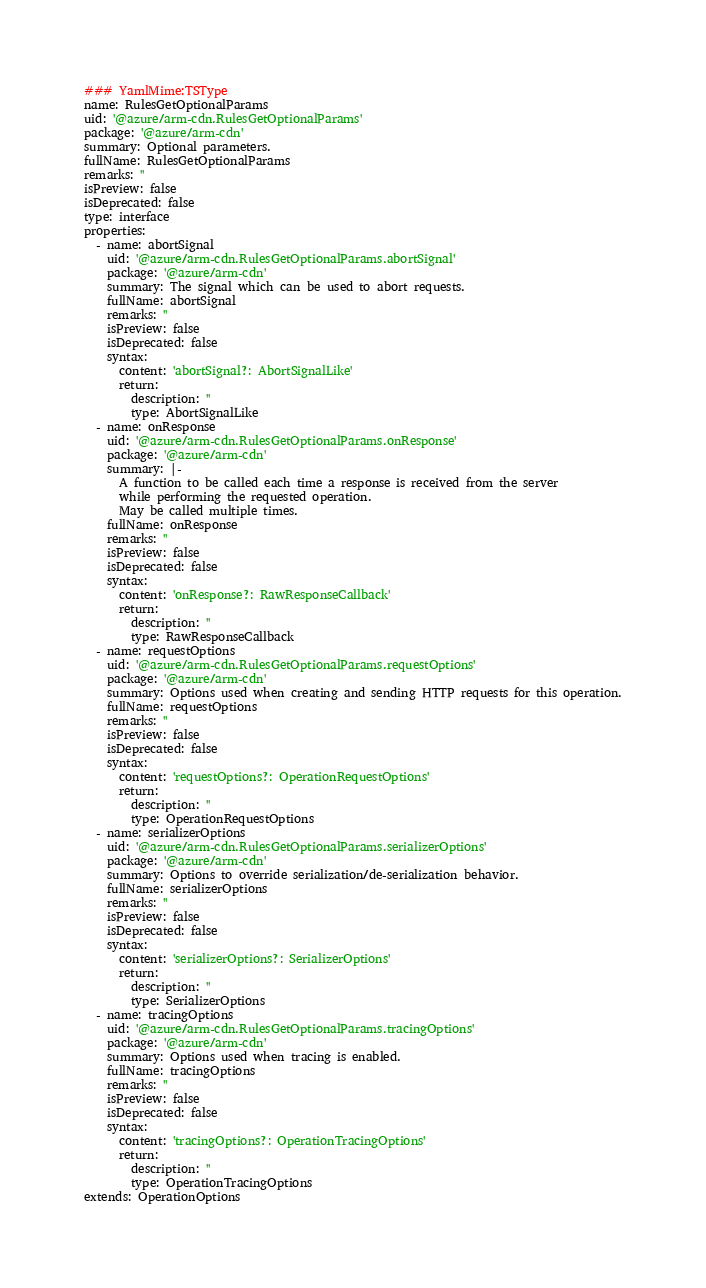<code> <loc_0><loc_0><loc_500><loc_500><_YAML_>### YamlMime:TSType
name: RulesGetOptionalParams
uid: '@azure/arm-cdn.RulesGetOptionalParams'
package: '@azure/arm-cdn'
summary: Optional parameters.
fullName: RulesGetOptionalParams
remarks: ''
isPreview: false
isDeprecated: false
type: interface
properties:
  - name: abortSignal
    uid: '@azure/arm-cdn.RulesGetOptionalParams.abortSignal'
    package: '@azure/arm-cdn'
    summary: The signal which can be used to abort requests.
    fullName: abortSignal
    remarks: ''
    isPreview: false
    isDeprecated: false
    syntax:
      content: 'abortSignal?: AbortSignalLike'
      return:
        description: ''
        type: AbortSignalLike
  - name: onResponse
    uid: '@azure/arm-cdn.RulesGetOptionalParams.onResponse'
    package: '@azure/arm-cdn'
    summary: |-
      A function to be called each time a response is received from the server
      while performing the requested operation.
      May be called multiple times.
    fullName: onResponse
    remarks: ''
    isPreview: false
    isDeprecated: false
    syntax:
      content: 'onResponse?: RawResponseCallback'
      return:
        description: ''
        type: RawResponseCallback
  - name: requestOptions
    uid: '@azure/arm-cdn.RulesGetOptionalParams.requestOptions'
    package: '@azure/arm-cdn'
    summary: Options used when creating and sending HTTP requests for this operation.
    fullName: requestOptions
    remarks: ''
    isPreview: false
    isDeprecated: false
    syntax:
      content: 'requestOptions?: OperationRequestOptions'
      return:
        description: ''
        type: OperationRequestOptions
  - name: serializerOptions
    uid: '@azure/arm-cdn.RulesGetOptionalParams.serializerOptions'
    package: '@azure/arm-cdn'
    summary: Options to override serialization/de-serialization behavior.
    fullName: serializerOptions
    remarks: ''
    isPreview: false
    isDeprecated: false
    syntax:
      content: 'serializerOptions?: SerializerOptions'
      return:
        description: ''
        type: SerializerOptions
  - name: tracingOptions
    uid: '@azure/arm-cdn.RulesGetOptionalParams.tracingOptions'
    package: '@azure/arm-cdn'
    summary: Options used when tracing is enabled.
    fullName: tracingOptions
    remarks: ''
    isPreview: false
    isDeprecated: false
    syntax:
      content: 'tracingOptions?: OperationTracingOptions'
      return:
        description: ''
        type: OperationTracingOptions
extends: OperationOptions
</code> 